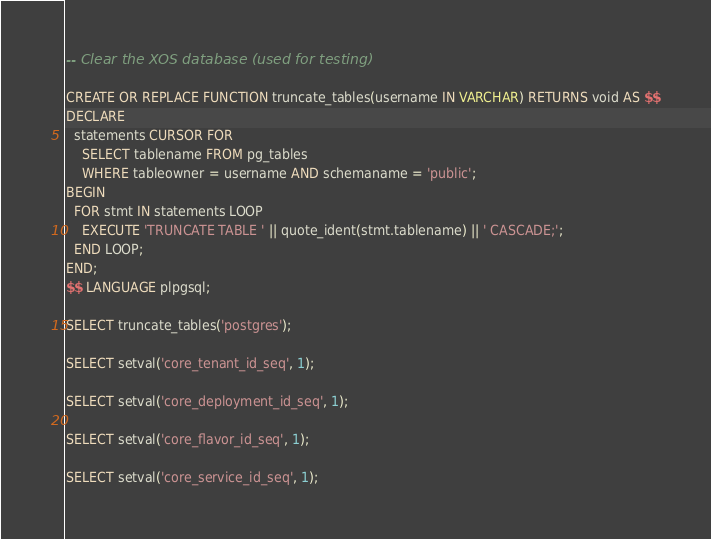<code> <loc_0><loc_0><loc_500><loc_500><_SQL_>-- Clear the XOS database (used for testing)

CREATE OR REPLACE FUNCTION truncate_tables(username IN VARCHAR) RETURNS void AS $$
DECLARE
  statements CURSOR FOR
    SELECT tablename FROM pg_tables
    WHERE tableowner = username AND schemaname = 'public';
BEGIN
  FOR stmt IN statements LOOP
    EXECUTE 'TRUNCATE TABLE ' || quote_ident(stmt.tablename) || ' CASCADE;';
  END LOOP;
END;
$$ LANGUAGE plpgsql;

SELECT truncate_tables('postgres');

SELECT setval('core_tenant_id_seq', 1);

SELECT setval('core_deployment_id_seq', 1);

SELECT setval('core_flavor_id_seq', 1);

SELECT setval('core_service_id_seq', 1);

</code> 